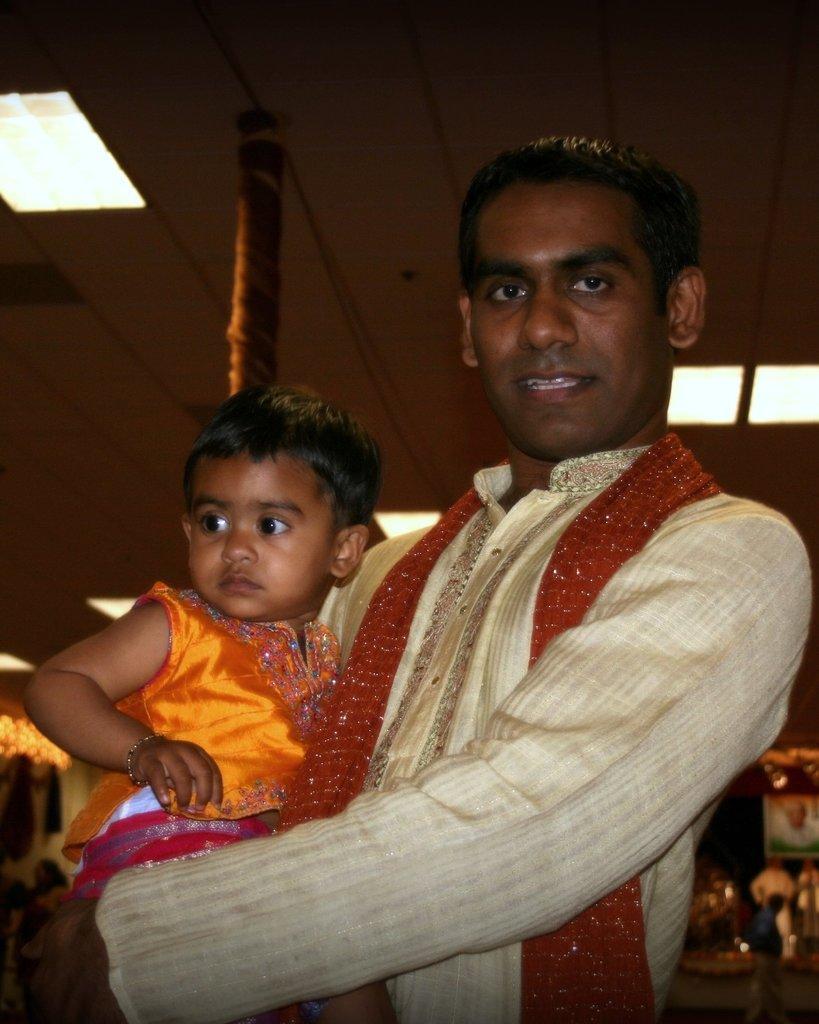Please provide a concise description of this image. In this picture I can observe a man holding a baby in his hands. He is wearing cream color dress. The baby is wearing an orange color dress. In the background I can observe a pole and some lights in the ceiling. 